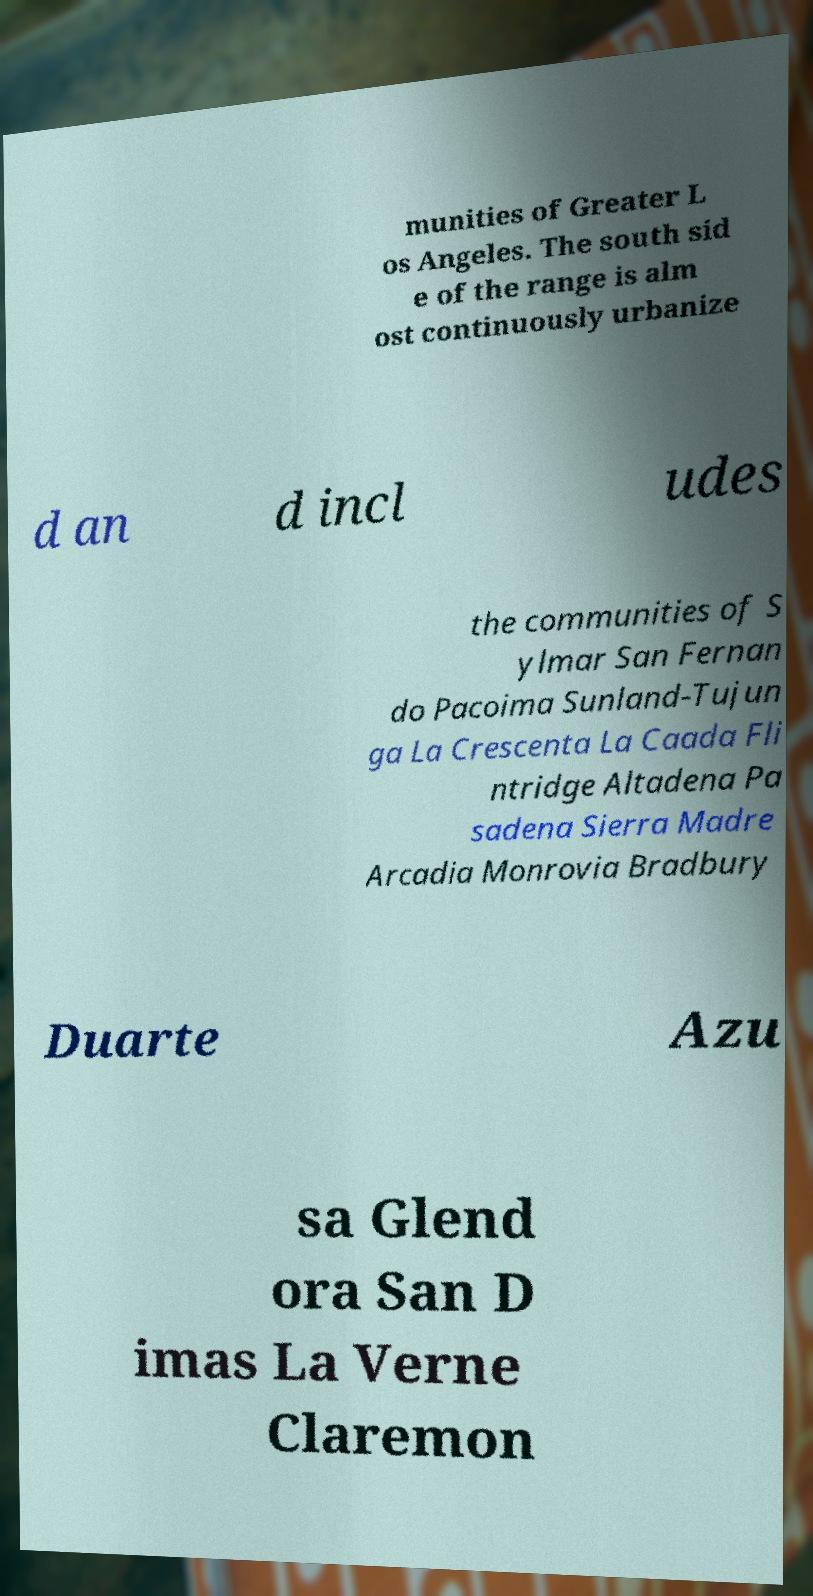I need the written content from this picture converted into text. Can you do that? munities of Greater L os Angeles. The south sid e of the range is alm ost continuously urbanize d an d incl udes the communities of S ylmar San Fernan do Pacoima Sunland-Tujun ga La Crescenta La Caada Fli ntridge Altadena Pa sadena Sierra Madre Arcadia Monrovia Bradbury Duarte Azu sa Glend ora San D imas La Verne Claremon 